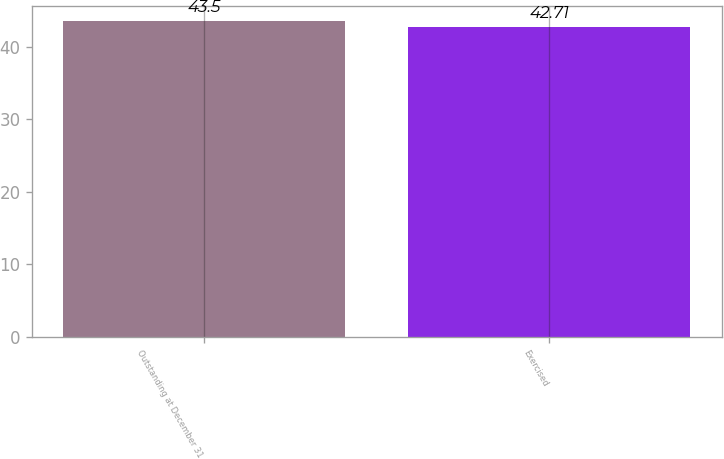Convert chart. <chart><loc_0><loc_0><loc_500><loc_500><bar_chart><fcel>Outstanding at December 31<fcel>Exercised<nl><fcel>43.5<fcel>42.71<nl></chart> 